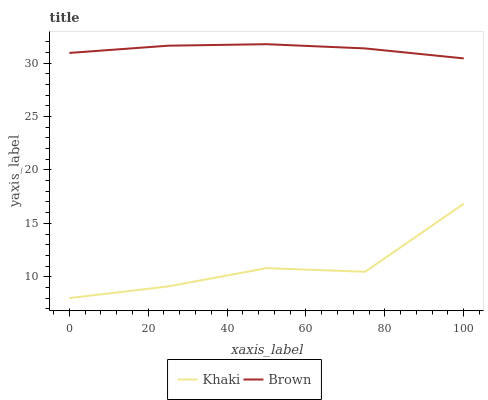Does Khaki have the minimum area under the curve?
Answer yes or no. Yes. Does Brown have the maximum area under the curve?
Answer yes or no. Yes. Does Khaki have the maximum area under the curve?
Answer yes or no. No. Is Brown the smoothest?
Answer yes or no. Yes. Is Khaki the roughest?
Answer yes or no. Yes. Is Khaki the smoothest?
Answer yes or no. No. Does Khaki have the lowest value?
Answer yes or no. Yes. Does Brown have the highest value?
Answer yes or no. Yes. Does Khaki have the highest value?
Answer yes or no. No. Is Khaki less than Brown?
Answer yes or no. Yes. Is Brown greater than Khaki?
Answer yes or no. Yes. Does Khaki intersect Brown?
Answer yes or no. No. 